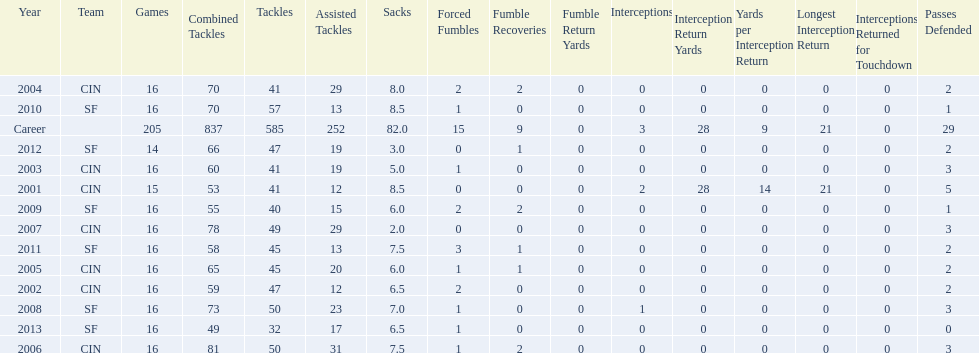How many seasons had combined tackles of 70 or more? 5. 